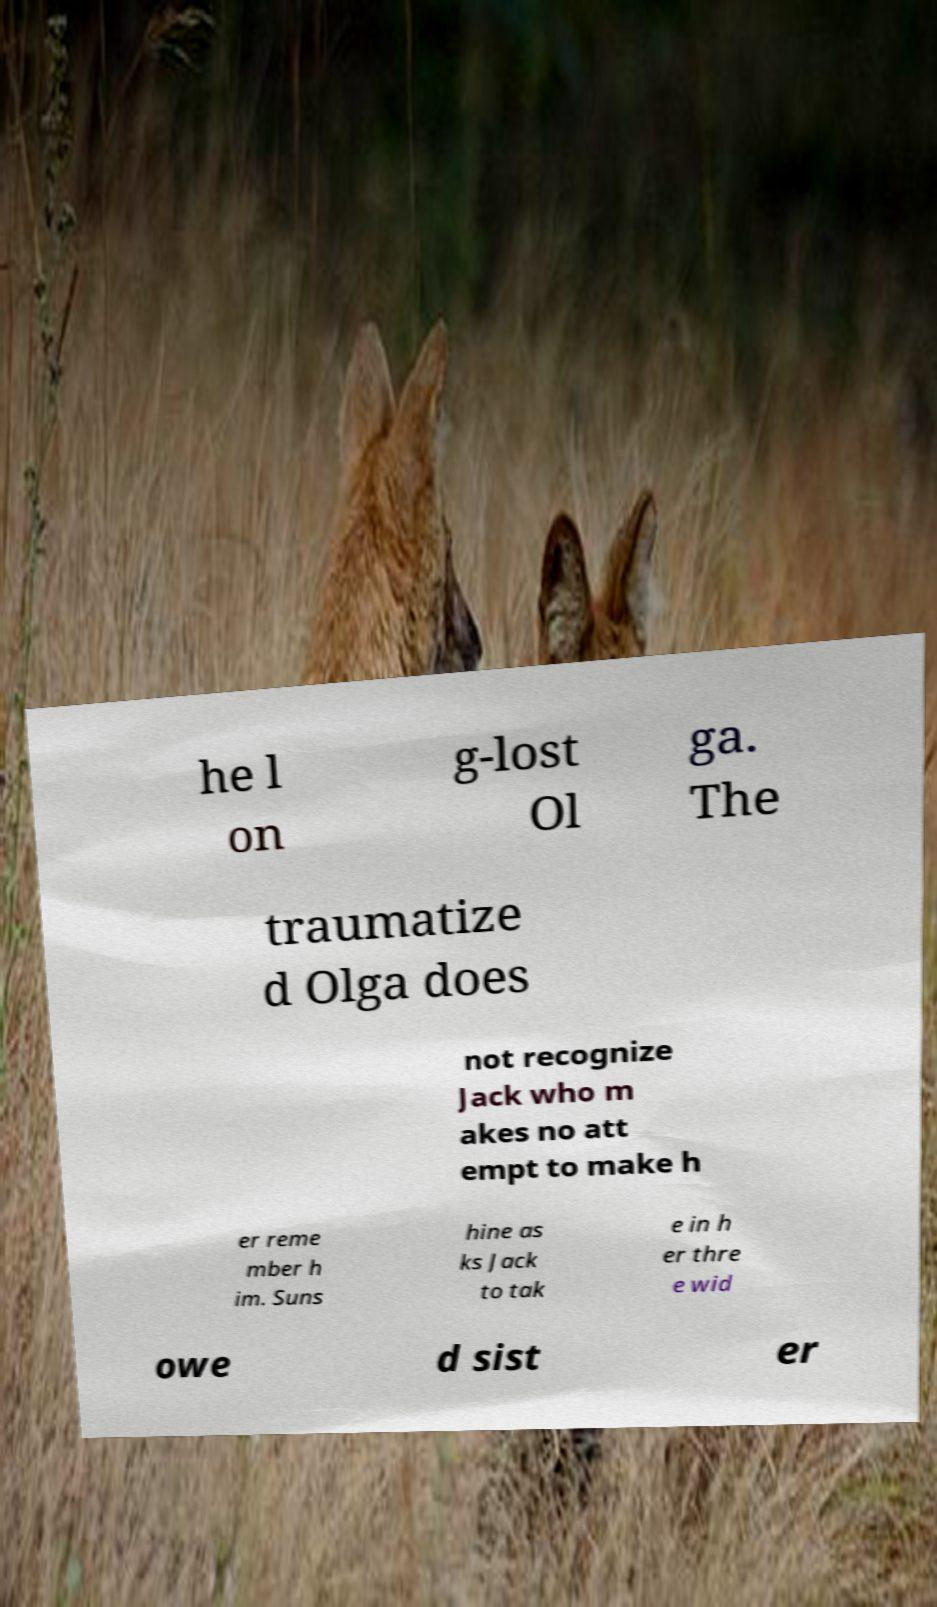Could you assist in decoding the text presented in this image and type it out clearly? he l on g-lost Ol ga. The traumatize d Olga does not recognize Jack who m akes no att empt to make h er reme mber h im. Suns hine as ks Jack to tak e in h er thre e wid owe d sist er 